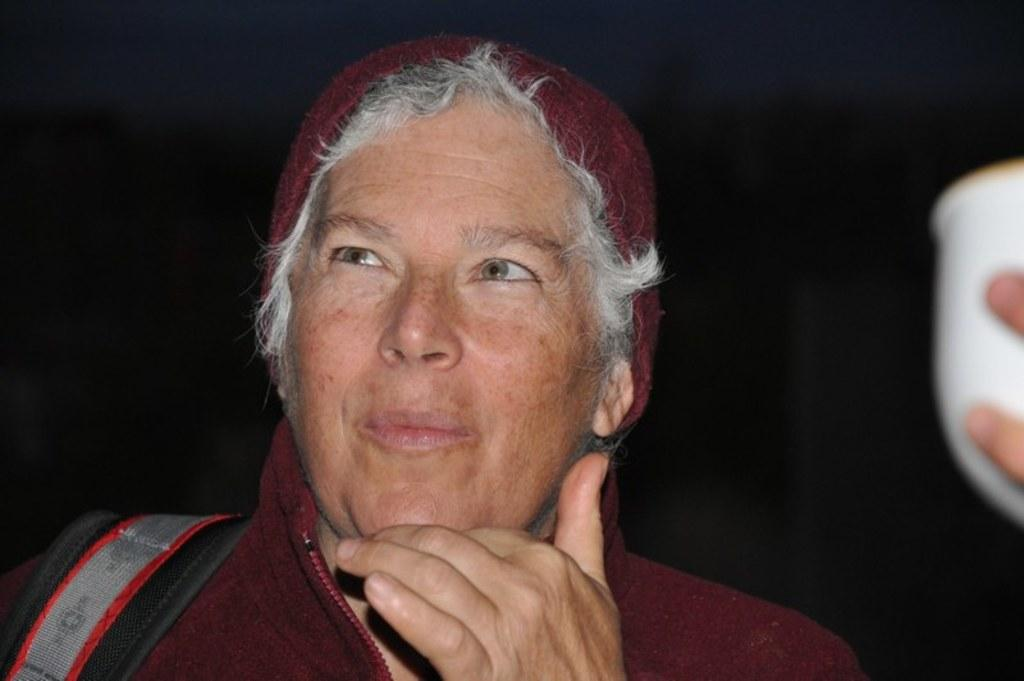What is the person on the left side of the image wearing? The person on the left side of the image is wearing a red dress. What is the person on the left side holding? The person on the left side is holding a bag. Can you describe the person on the right side of the image? The person on the right side of the image is holding a white cup. What type of prison can be seen in the background of the image? There is no prison visible in the image; it only features two people, one holding a bag and the other holding a white cup. 